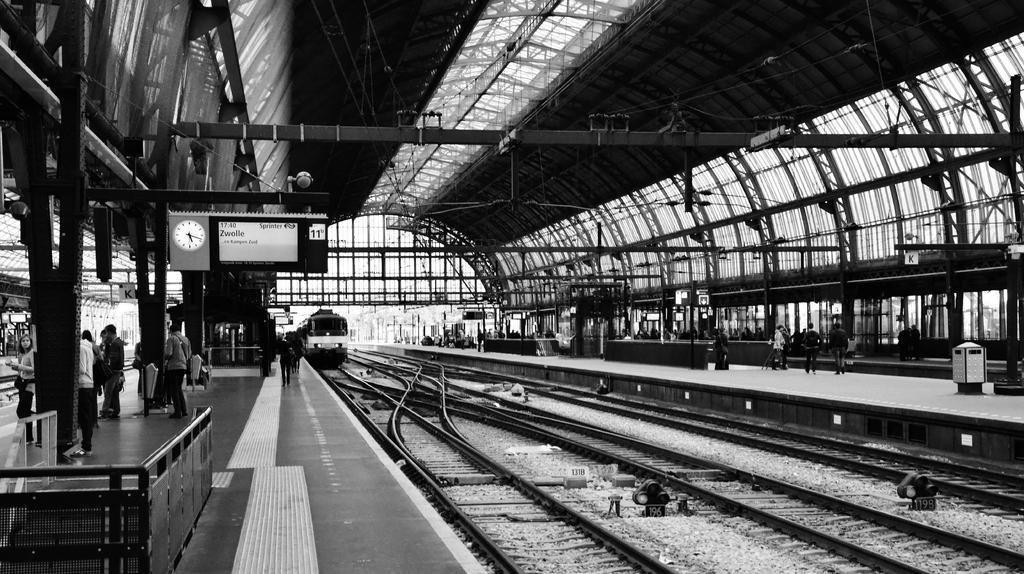Describe this image in one or two sentences. This image consists of a railway station. In the front, we can see a train. At the bottom, there are tracks. On the left and right, there are platforms. And we can see many people in this image. At the top, there is a roof. 